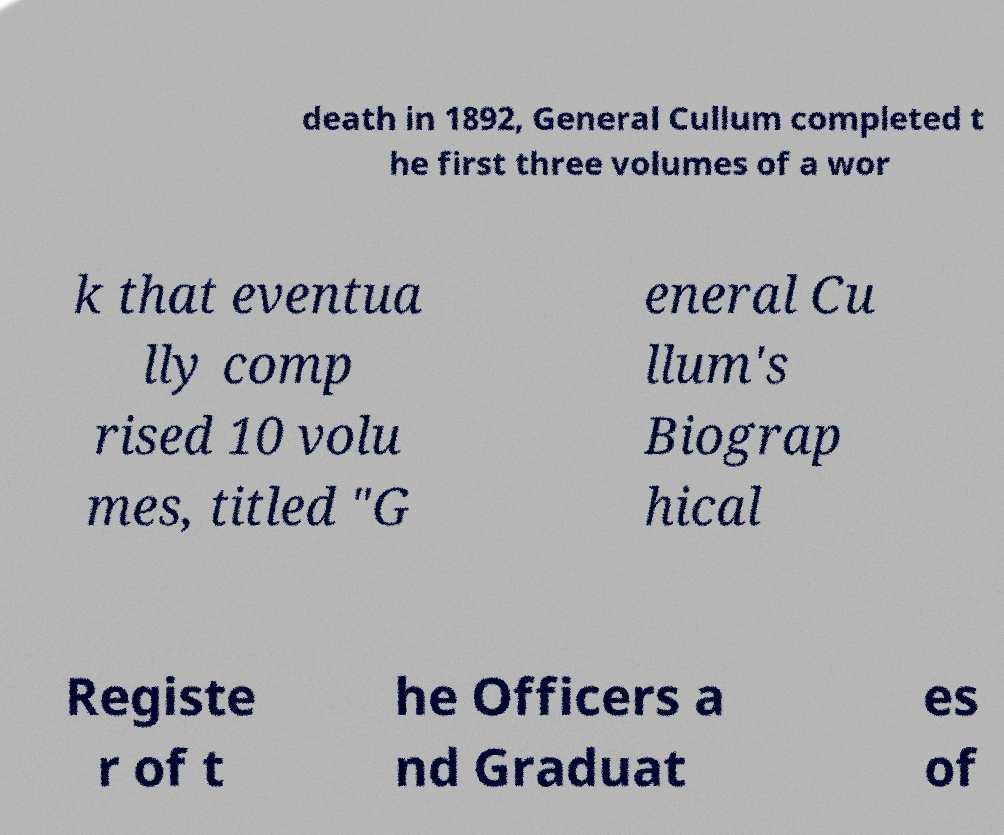I need the written content from this picture converted into text. Can you do that? death in 1892, General Cullum completed t he first three volumes of a wor k that eventua lly comp rised 10 volu mes, titled "G eneral Cu llum's Biograp hical Registe r of t he Officers a nd Graduat es of 